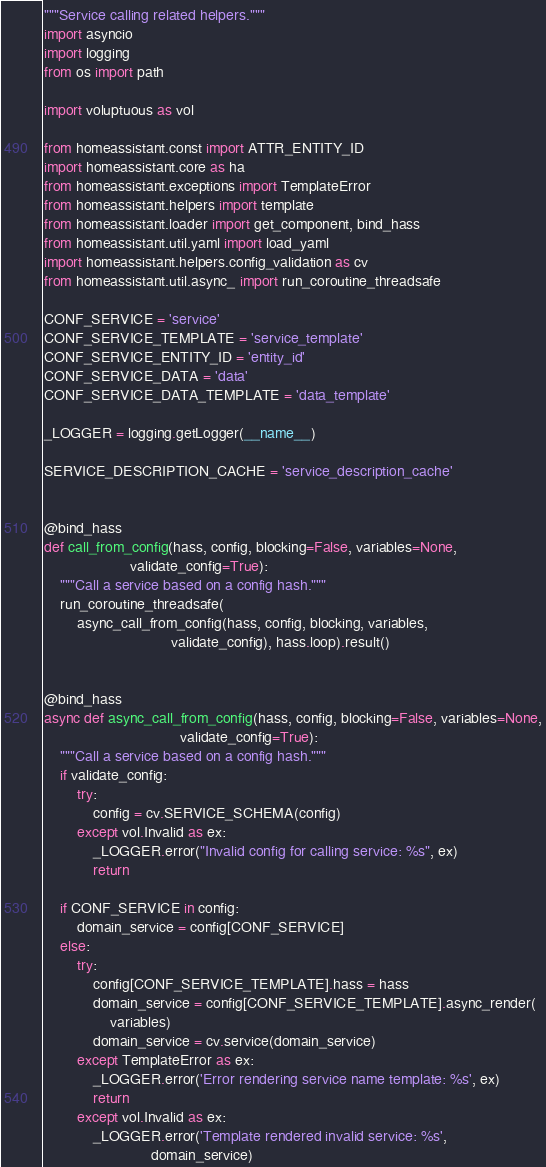Convert code to text. <code><loc_0><loc_0><loc_500><loc_500><_Python_>"""Service calling related helpers."""
import asyncio
import logging
from os import path

import voluptuous as vol

from homeassistant.const import ATTR_ENTITY_ID
import homeassistant.core as ha
from homeassistant.exceptions import TemplateError
from homeassistant.helpers import template
from homeassistant.loader import get_component, bind_hass
from homeassistant.util.yaml import load_yaml
import homeassistant.helpers.config_validation as cv
from homeassistant.util.async_ import run_coroutine_threadsafe

CONF_SERVICE = 'service'
CONF_SERVICE_TEMPLATE = 'service_template'
CONF_SERVICE_ENTITY_ID = 'entity_id'
CONF_SERVICE_DATA = 'data'
CONF_SERVICE_DATA_TEMPLATE = 'data_template'

_LOGGER = logging.getLogger(__name__)

SERVICE_DESCRIPTION_CACHE = 'service_description_cache'


@bind_hass
def call_from_config(hass, config, blocking=False, variables=None,
                     validate_config=True):
    """Call a service based on a config hash."""
    run_coroutine_threadsafe(
        async_call_from_config(hass, config, blocking, variables,
                               validate_config), hass.loop).result()


@bind_hass
async def async_call_from_config(hass, config, blocking=False, variables=None,
                                 validate_config=True):
    """Call a service based on a config hash."""
    if validate_config:
        try:
            config = cv.SERVICE_SCHEMA(config)
        except vol.Invalid as ex:
            _LOGGER.error("Invalid config for calling service: %s", ex)
            return

    if CONF_SERVICE in config:
        domain_service = config[CONF_SERVICE]
    else:
        try:
            config[CONF_SERVICE_TEMPLATE].hass = hass
            domain_service = config[CONF_SERVICE_TEMPLATE].async_render(
                variables)
            domain_service = cv.service(domain_service)
        except TemplateError as ex:
            _LOGGER.error('Error rendering service name template: %s', ex)
            return
        except vol.Invalid as ex:
            _LOGGER.error('Template rendered invalid service: %s',
                          domain_service)</code> 